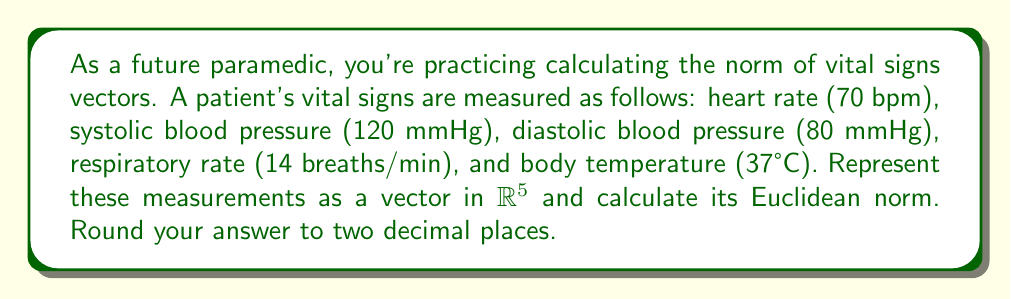Give your solution to this math problem. To solve this problem, we'll follow these steps:

1) First, let's represent the vital signs as a vector in $\mathbb{R}^5$:

   $v = (70, 120, 80, 14, 37)$

2) The Euclidean norm (also known as L2 norm) of a vector $x = (x_1, x_2, ..., x_n)$ is defined as:

   $\|x\|_2 = \sqrt{\sum_{i=1}^n |x_i|^2}$

3) For our vector $v$, we need to calculate:

   $\|v\|_2 = \sqrt{70^2 + 120^2 + 80^2 + 14^2 + 37^2}$

4) Let's compute each term:
   
   $70^2 = 4900$
   $120^2 = 14400$
   $80^2 = 6400$
   $14^2 = 196$
   $37^2 = 1369$

5) Sum these values:

   $4900 + 14400 + 6400 + 196 + 1369 = 27265$

6) Take the square root:

   $\sqrt{27265} \approx 165.12$

7) Rounding to two decimal places gives us 165.12.
Answer: $\|v\|_2 \approx 165.12$ 